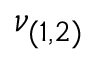<formula> <loc_0><loc_0><loc_500><loc_500>\nu _ { ( 1 , 2 ) }</formula> 